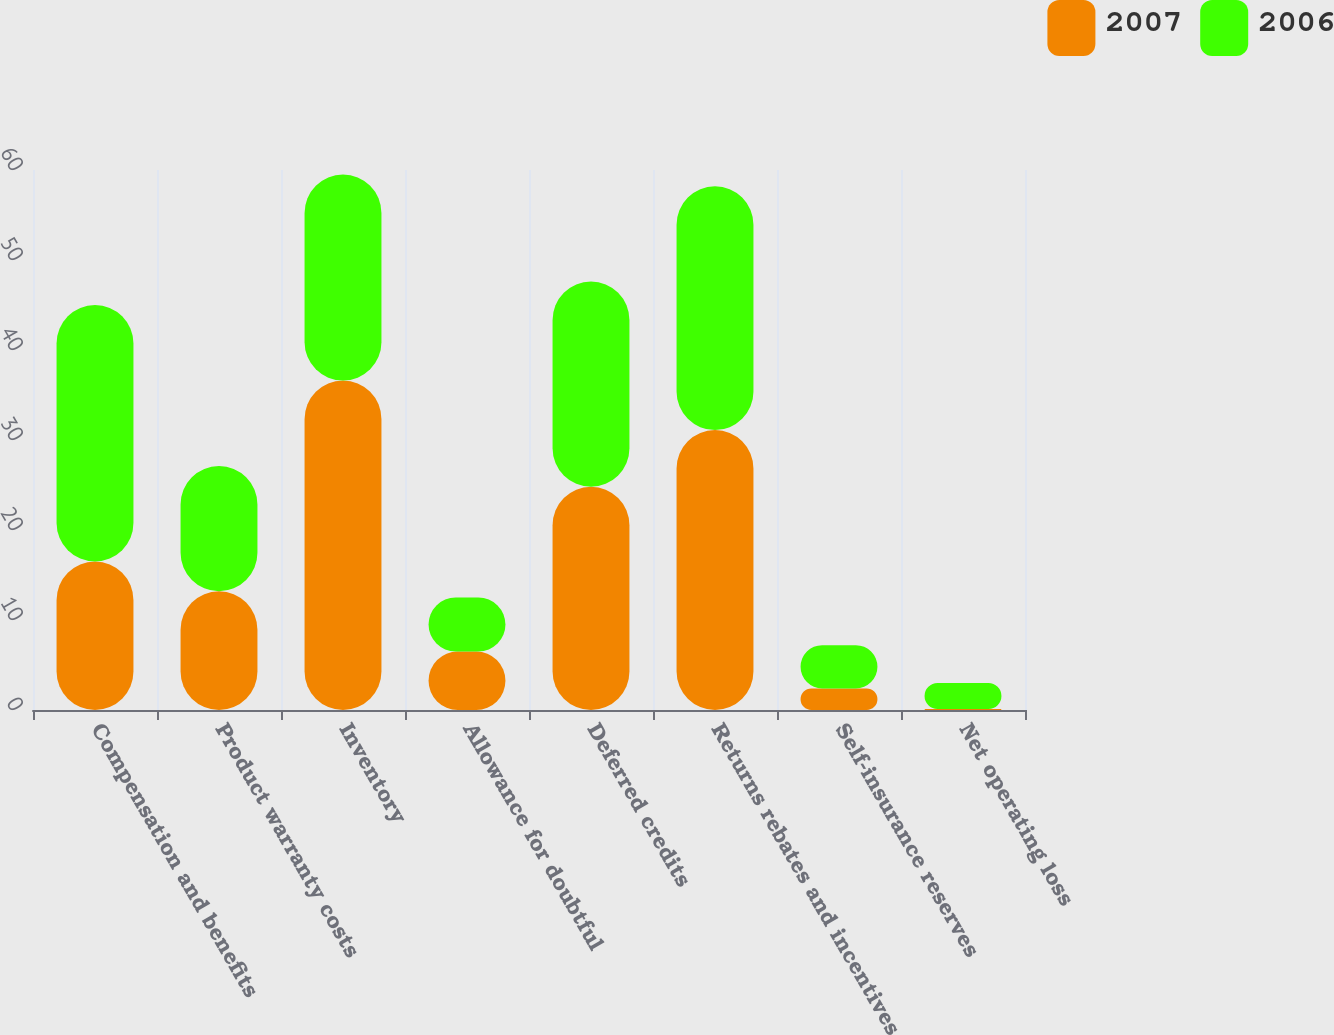Convert chart. <chart><loc_0><loc_0><loc_500><loc_500><stacked_bar_chart><ecel><fcel>Compensation and benefits<fcel>Product warranty costs<fcel>Inventory<fcel>Allowance for doubtful<fcel>Deferred credits<fcel>Returns rebates and incentives<fcel>Self-insurance reserves<fcel>Net operating loss<nl><fcel>2007<fcel>16.5<fcel>13.2<fcel>36.6<fcel>6.5<fcel>24.8<fcel>31.1<fcel>2.4<fcel>0.1<nl><fcel>2006<fcel>28.5<fcel>13.9<fcel>22.9<fcel>6<fcel>22.8<fcel>27.1<fcel>4.8<fcel>2.9<nl></chart> 